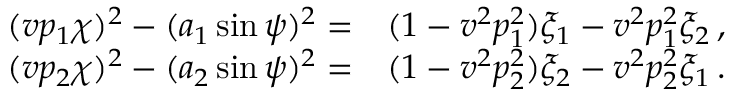Convert formula to latex. <formula><loc_0><loc_0><loc_500><loc_500>\begin{array} { r l } { ( v p _ { 1 } \chi ) ^ { 2 } - ( a _ { 1 } \sin \psi ) ^ { 2 } = } & ( 1 - v ^ { 2 } p _ { 1 } ^ { 2 } ) \xi _ { 1 } - v ^ { 2 } p _ { 1 } ^ { 2 } \xi _ { 2 } \, , } \\ { ( v p _ { 2 } \chi ) ^ { 2 } - ( a _ { 2 } \sin \psi ) ^ { 2 } = } & ( 1 - v ^ { 2 } p _ { 2 } ^ { 2 } ) \xi _ { 2 } - v ^ { 2 } p _ { 2 } ^ { 2 } \xi _ { 1 } \, . } \end{array}</formula> 